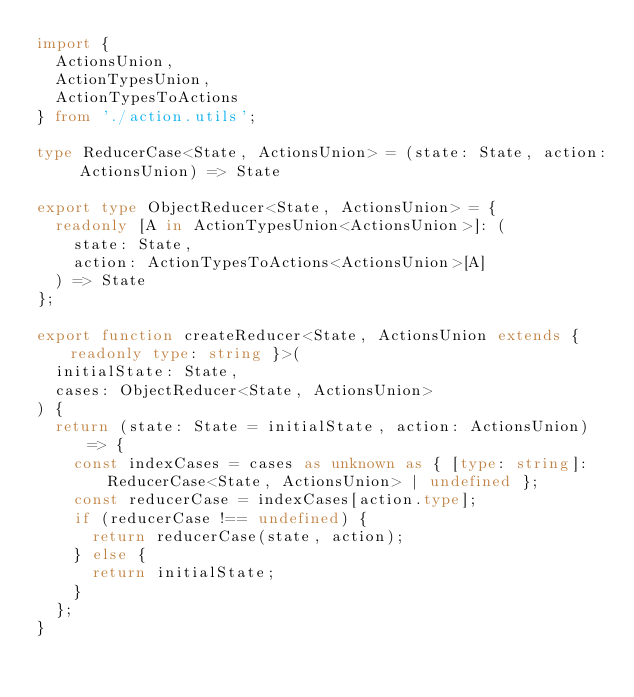Convert code to text. <code><loc_0><loc_0><loc_500><loc_500><_TypeScript_>import {
  ActionsUnion,
  ActionTypesUnion,
  ActionTypesToActions
} from './action.utils';

type ReducerCase<State, ActionsUnion> = (state: State, action: ActionsUnion) => State

export type ObjectReducer<State, ActionsUnion> = {
  readonly [A in ActionTypesUnion<ActionsUnion>]: (
    state: State,
    action: ActionTypesToActions<ActionsUnion>[A]
  ) => State
};

export function createReducer<State, ActionsUnion extends { readonly type: string }>(
  initialState: State,
  cases: ObjectReducer<State, ActionsUnion>
) {
  return (state: State = initialState, action: ActionsUnion) => {
    const indexCases = cases as unknown as { [type: string]: ReducerCase<State, ActionsUnion> | undefined };
    const reducerCase = indexCases[action.type];
    if (reducerCase !== undefined) {
      return reducerCase(state, action);
    } else {
      return initialState;
    }
  };
}
</code> 